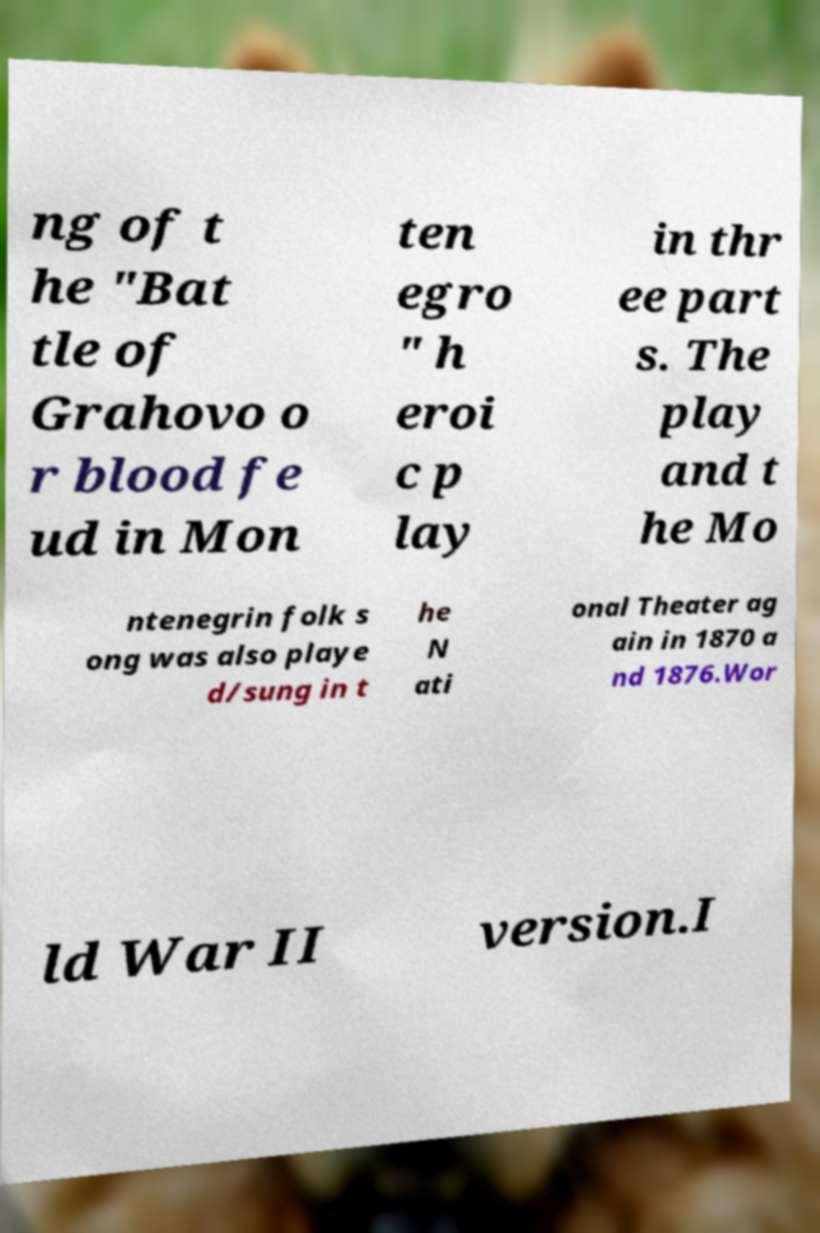What messages or text are displayed in this image? I need them in a readable, typed format. ng of t he "Bat tle of Grahovo o r blood fe ud in Mon ten egro " h eroi c p lay in thr ee part s. The play and t he Mo ntenegrin folk s ong was also playe d/sung in t he N ati onal Theater ag ain in 1870 a nd 1876.Wor ld War II version.I 